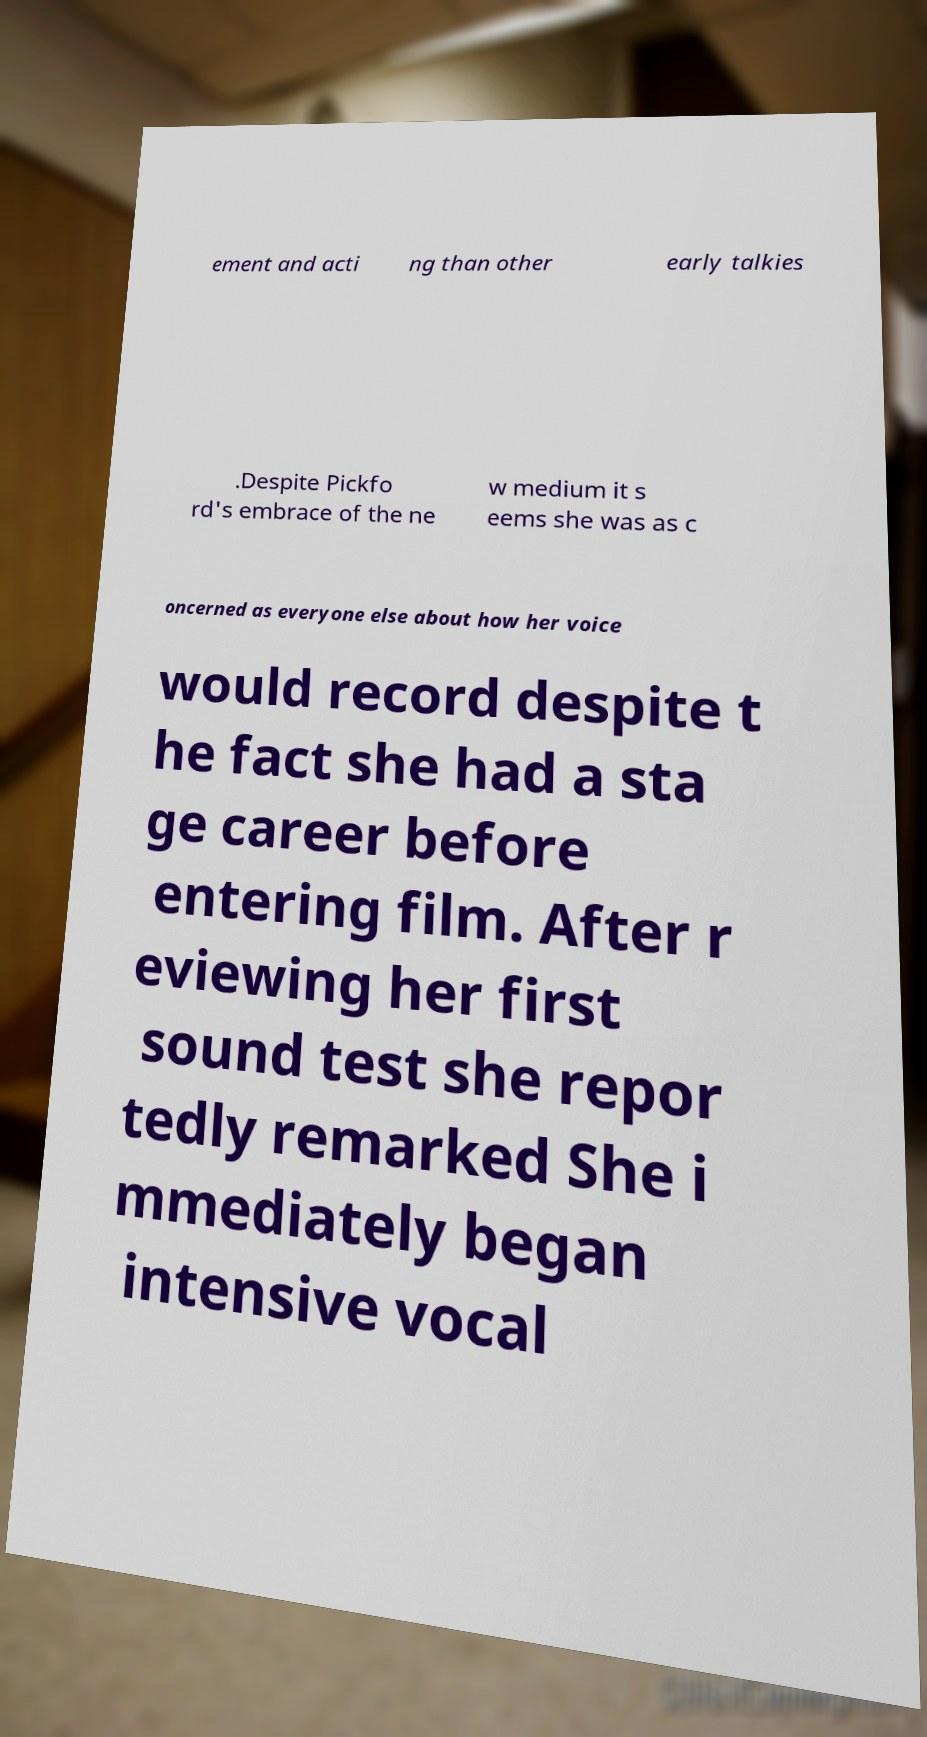Could you extract and type out the text from this image? ement and acti ng than other early talkies .Despite Pickfo rd's embrace of the ne w medium it s eems she was as c oncerned as everyone else about how her voice would record despite t he fact she had a sta ge career before entering film. After r eviewing her first sound test she repor tedly remarked She i mmediately began intensive vocal 